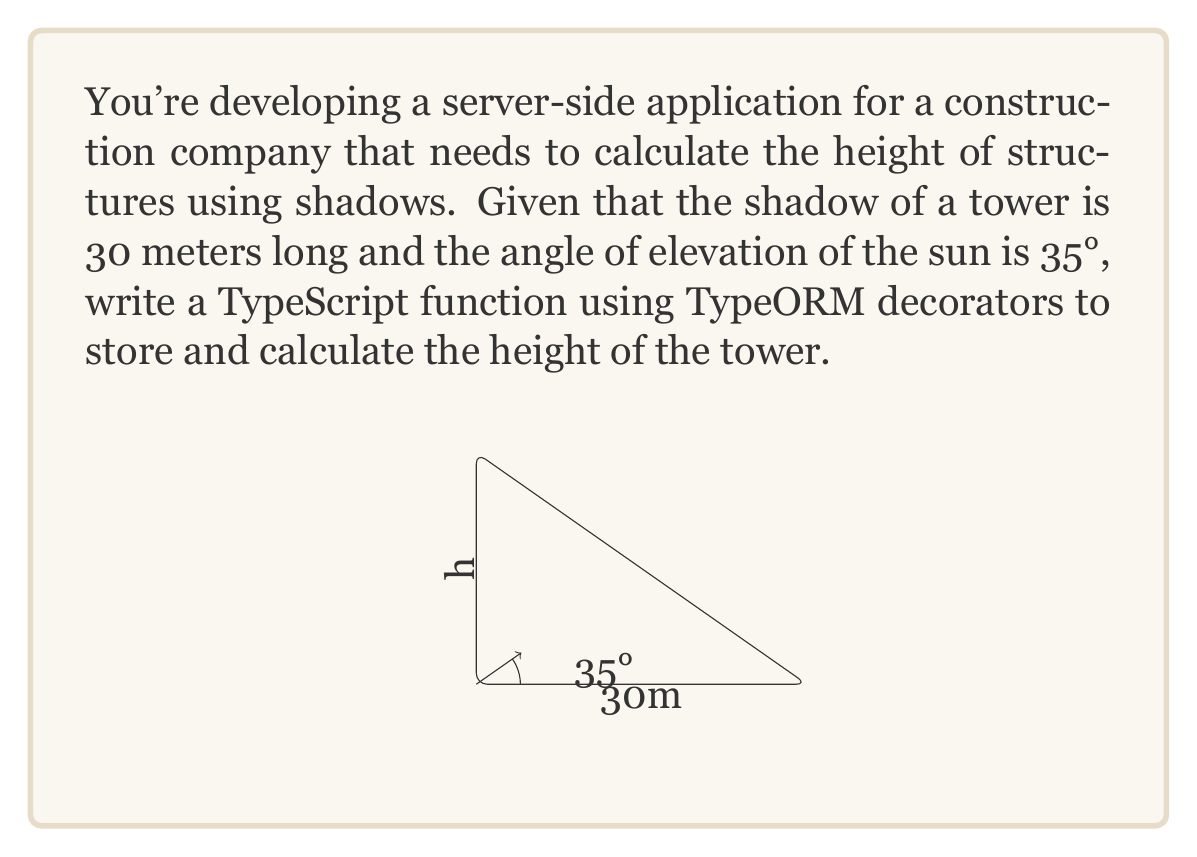Help me with this question. To solve this problem, we'll use the tangent trigonometric function. Here's a step-by-step explanation:

1. First, let's recall the tangent function:
   $$\tan(\theta) = \frac{\text{opposite}}{\text{adjacent}}$$

2. In our case:
   - The angle $\theta$ is 35°
   - The adjacent side is the shadow length, 30 meters
   - The opposite side is the tower height, which we need to find

3. Let's call the tower height $h$. We can set up the equation:
   $$\tan(35°) = \frac{h}{30}$$

4. To solve for $h$, we multiply both sides by 30:
   $$30 \cdot \tan(35°) = h$$

5. Now we can calculate the value:
   $$h = 30 \cdot \tan(35°) \approx 21.0$$

To implement this in TypeScript with TypeORM decorators, we could create an entity like this:

```typescript
import { Entity, Column, PrimaryGeneratedColumn } from "typeorm";

@Entity()
class Tower {
  @PrimaryGeneratedColumn()
  id: number;

  @Column("float")
  shadowLength: number;

  @Column("float")
  angleOfElevation: number;

  @Column("float", { nullable: true })
  height: number;

  calculateHeight(): number {
    this.height = this.shadowLength * Math.tan(this.angleOfElevation * Math.PI / 180);
    return this.height;
  }
}
```

This entity can be used to store tower data and calculate the height based on the shadow length and angle of elevation.
Answer: The height of the tower is approximately 21.0 meters. 